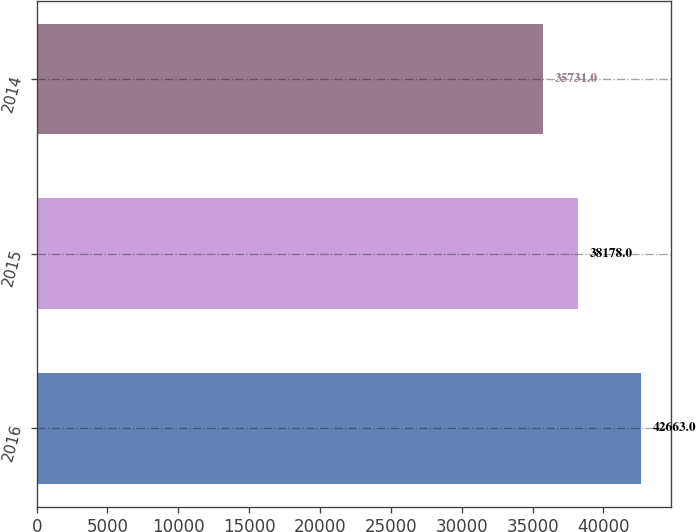<chart> <loc_0><loc_0><loc_500><loc_500><bar_chart><fcel>2016<fcel>2015<fcel>2014<nl><fcel>42663<fcel>38178<fcel>35731<nl></chart> 